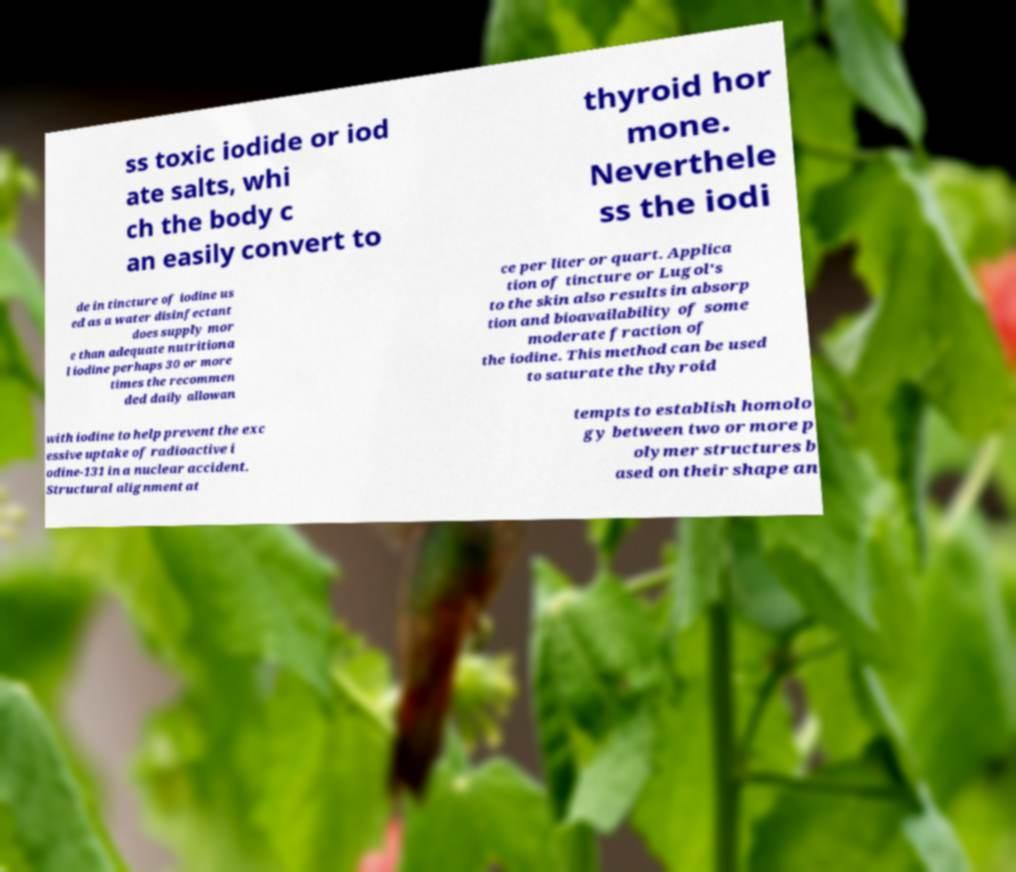Can you read and provide the text displayed in the image?This photo seems to have some interesting text. Can you extract and type it out for me? ss toxic iodide or iod ate salts, whi ch the body c an easily convert to thyroid hor mone. Neverthele ss the iodi de in tincture of iodine us ed as a water disinfectant does supply mor e than adequate nutritiona l iodine perhaps 30 or more times the recommen ded daily allowan ce per liter or quart. Applica tion of tincture or Lugol's to the skin also results in absorp tion and bioavailability of some moderate fraction of the iodine. This method can be used to saturate the thyroid with iodine to help prevent the exc essive uptake of radioactive i odine-131 in a nuclear accident. Structural alignment at tempts to establish homolo gy between two or more p olymer structures b ased on their shape an 